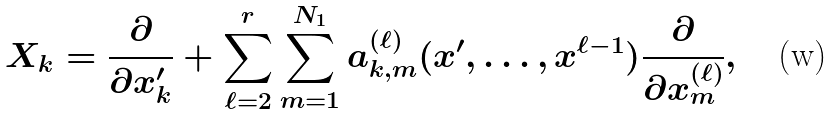<formula> <loc_0><loc_0><loc_500><loc_500>X _ { k } = \frac { \partial } { \partial x ^ { \prime } _ { k } } + \sum _ { \ell = 2 } ^ { r } \sum _ { m = 1 } ^ { N _ { 1 } } a _ { k , m } ^ { ( \ell ) } ( x ^ { \prime } , \dots , x ^ { \ell - 1 } ) \frac { \partial } { \partial x _ { m } ^ { ( \ell ) } } ,</formula> 